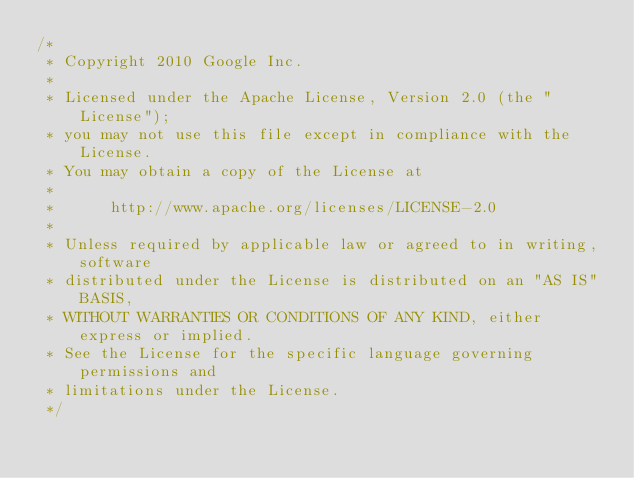Convert code to text. <code><loc_0><loc_0><loc_500><loc_500><_C_>/*
 * Copyright 2010 Google Inc.
 *
 * Licensed under the Apache License, Version 2.0 (the "License");
 * you may not use this file except in compliance with the License.
 * You may obtain a copy of the License at
 *
 *      http://www.apache.org/licenses/LICENSE-2.0
 *
 * Unless required by applicable law or agreed to in writing, software
 * distributed under the License is distributed on an "AS IS" BASIS,
 * WITHOUT WARRANTIES OR CONDITIONS OF ANY KIND, either express or implied.
 * See the License for the specific language governing permissions and
 * limitations under the License.
 */
</code> 